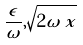<formula> <loc_0><loc_0><loc_500><loc_500>\frac { \epsilon } { \omega } , \sqrt { 2 \omega \, x }</formula> 